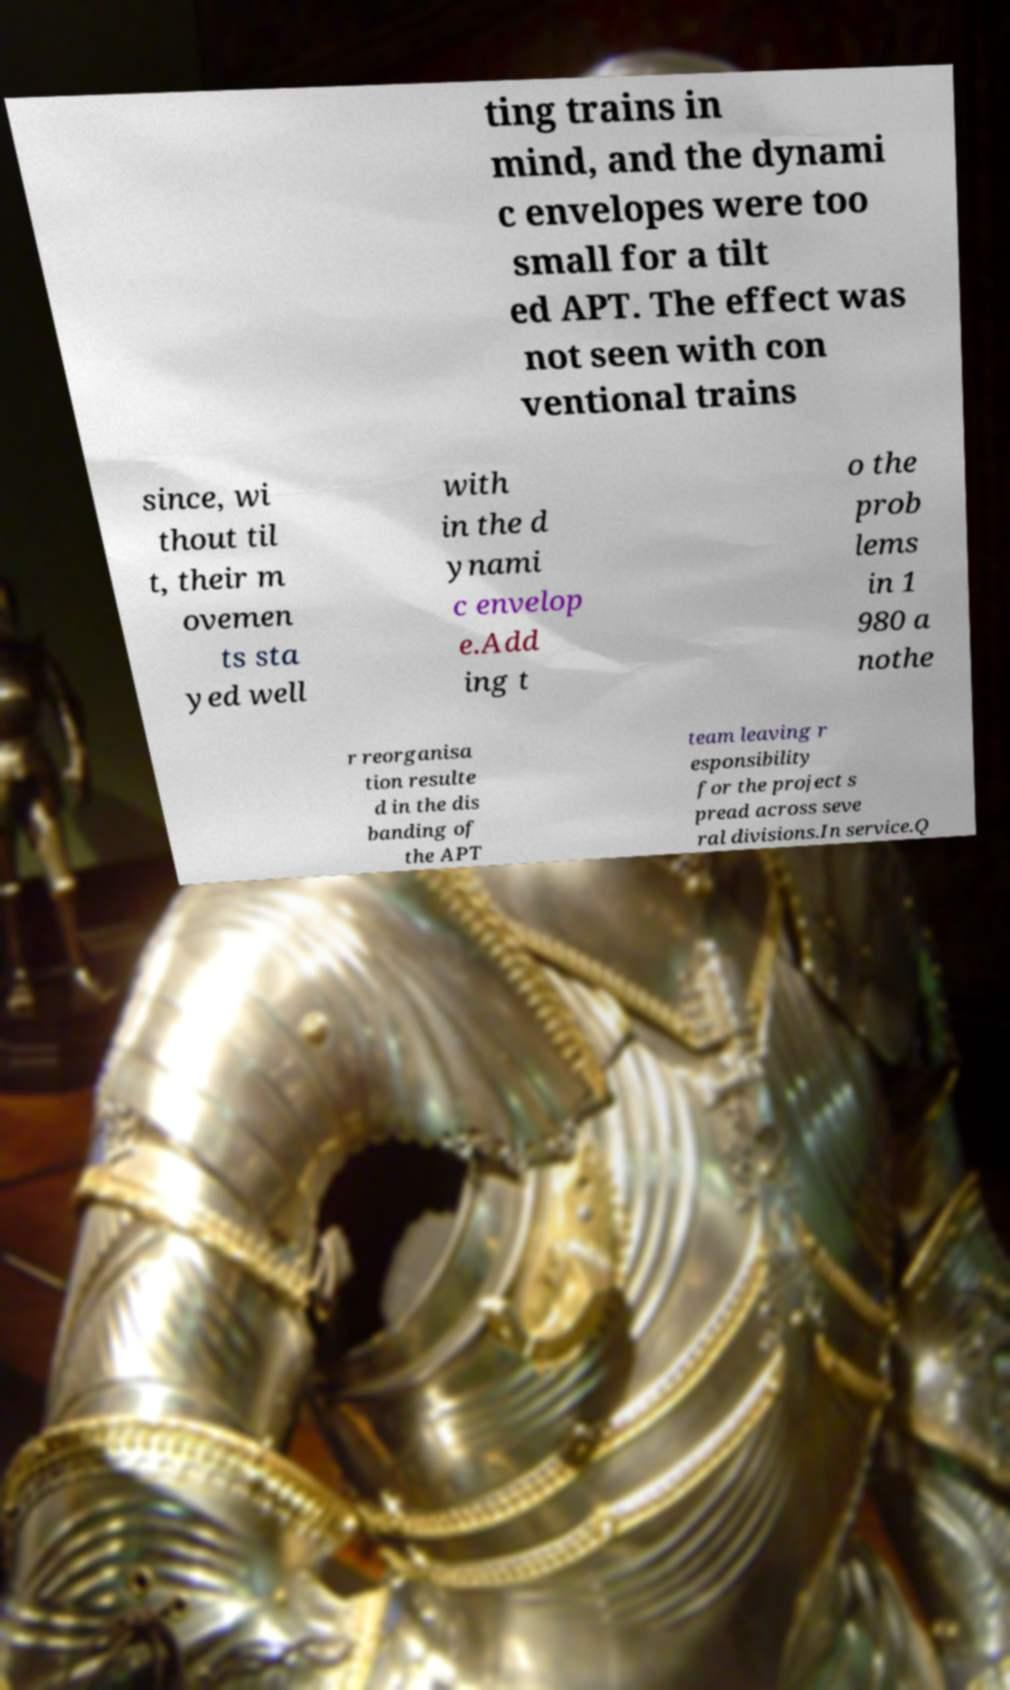I need the written content from this picture converted into text. Can you do that? ting trains in mind, and the dynami c envelopes were too small for a tilt ed APT. The effect was not seen with con ventional trains since, wi thout til t, their m ovemen ts sta yed well with in the d ynami c envelop e.Add ing t o the prob lems in 1 980 a nothe r reorganisa tion resulte d in the dis banding of the APT team leaving r esponsibility for the project s pread across seve ral divisions.In service.Q 